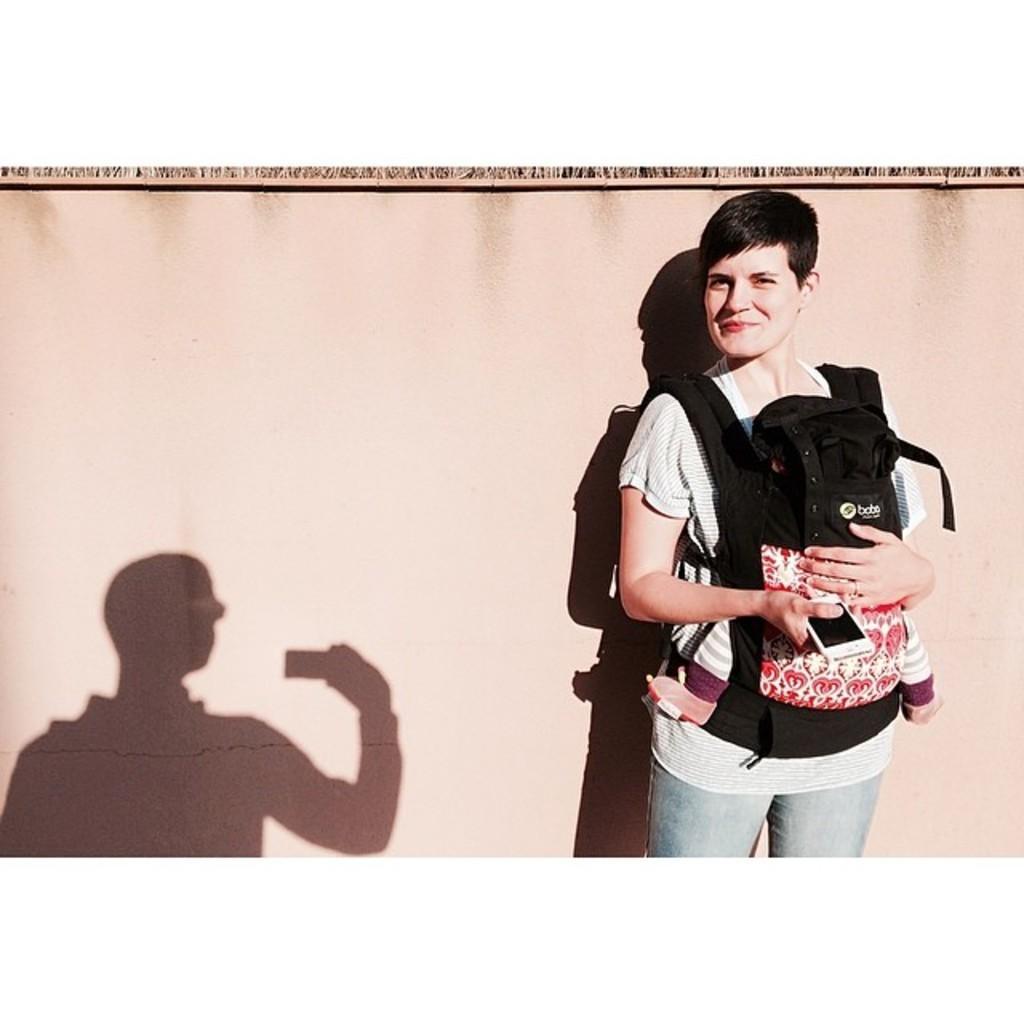Describe this image in one or two sentences. In this picture I can see a person holding the baby on the right side. I can see the shadow of a person on the left side. I can see the brown color in the background. 